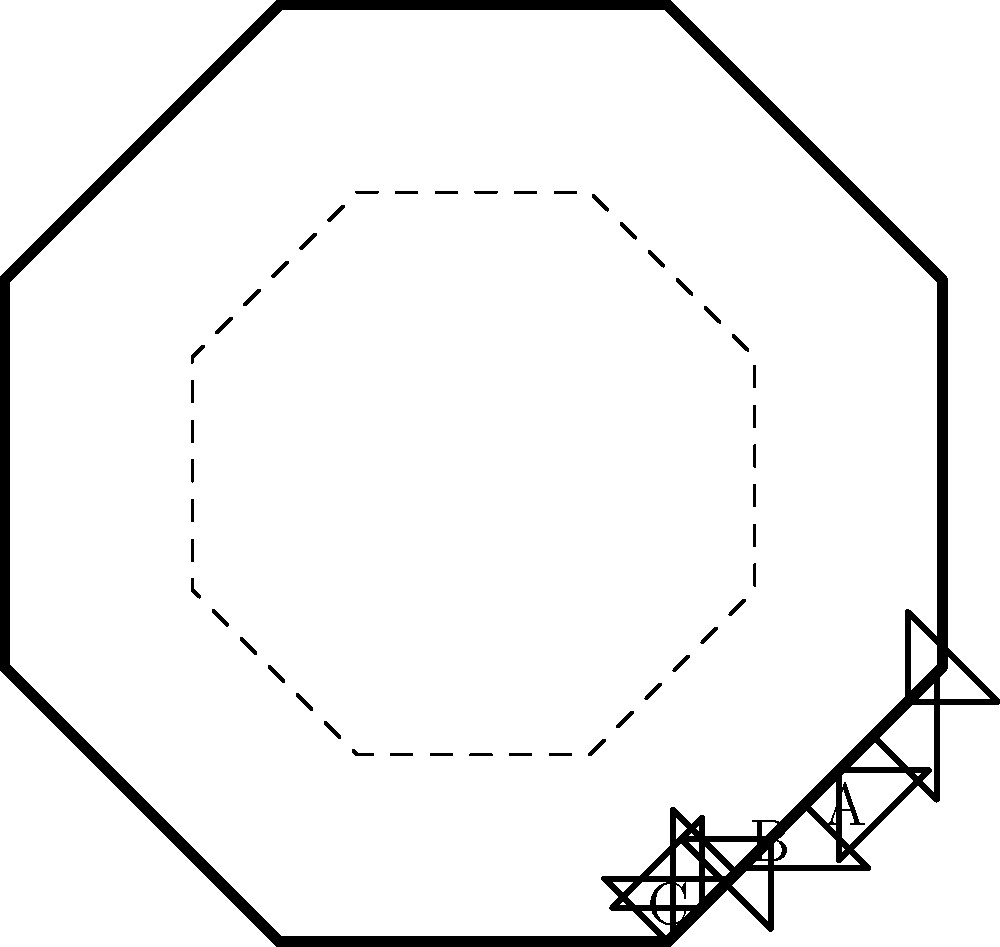Examine the antique frame design shown in the image. Which period does this frame likely belong to, based on its shape and ornamental features?

A) Baroque
B) Rococo
C) Neoclassical To identify the provenance of this antique frame, let's analyze its key features step-by-step:

1. Shape: The frame has an octagonal shape, which is less common in earlier periods like Baroque or Rococo. This geometric form is more associated with Neoclassical design.

2. Ornaments: The frame features simple, symmetrical ornaments at each corner and midpoint of the sides. These ornaments are restrained and geometric, lacking the elaborate scrollwork or naturalistic motifs typical of Baroque or Rococo styles.

3. Overall design: The frame's design emphasizes clean lines, symmetry, and geometric shapes. This aligns with Neoclassical principles inspired by ancient Greek and Roman architecture.

4. Inner frame: The presence of a simple, dashed inner frame further emphasizes the geometric nature of the design, which is characteristic of Neoclassical style.

5. Lack of curves: Unlike Baroque or Rococo frames, which often feature curvilinear shapes and flowing lines, this frame is composed entirely of straight lines and sharp angles.

6. Historical context: The Neoclassical period (approximately 1760-1830) followed the Rococo era and was characterized by a return to classical simplicity and order in reaction to the perceived excesses of earlier styles.

Given these observations, particularly the emphasis on geometric shapes, symmetry, and restrained ornamentation, this frame most likely belongs to the Neoclassical period.
Answer: Neoclassical 